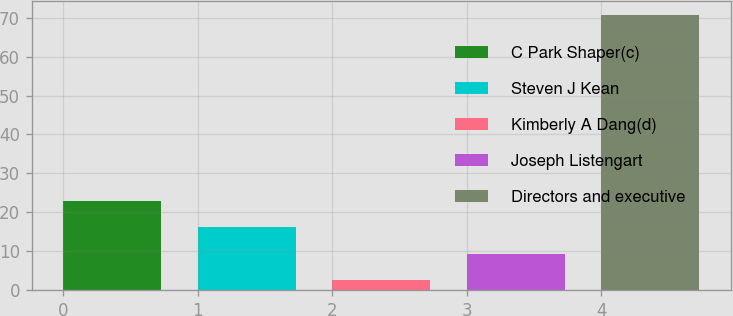<chart> <loc_0><loc_0><loc_500><loc_500><bar_chart><fcel>C Park Shaper(c)<fcel>Steven J Kean<fcel>Kimberly A Dang(d)<fcel>Joseph Listengart<fcel>Directors and executive<nl><fcel>22.99<fcel>16.16<fcel>2.5<fcel>9.33<fcel>70.8<nl></chart> 